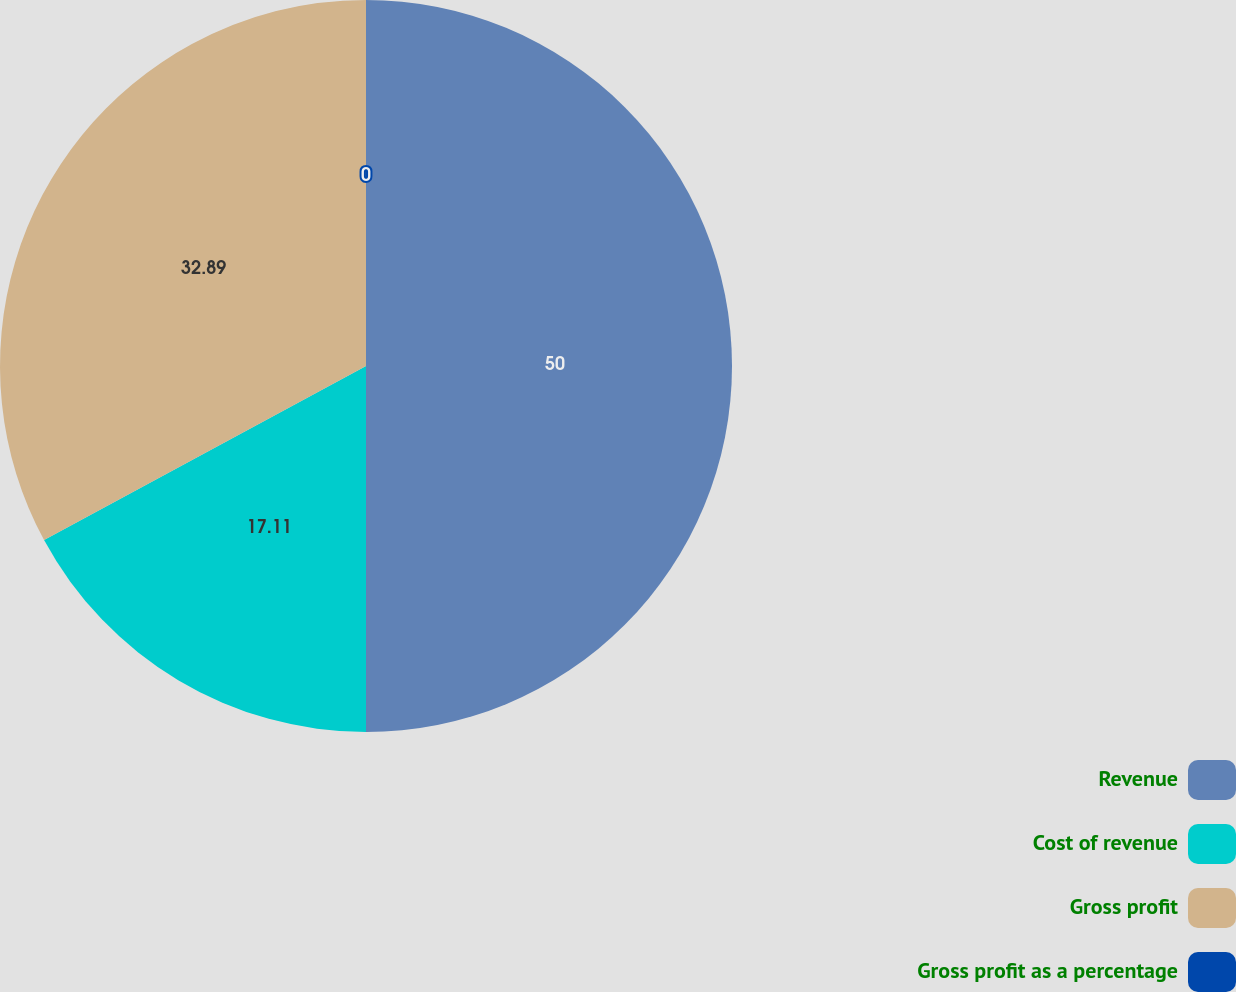Convert chart. <chart><loc_0><loc_0><loc_500><loc_500><pie_chart><fcel>Revenue<fcel>Cost of revenue<fcel>Gross profit<fcel>Gross profit as a percentage<nl><fcel>50.0%<fcel>17.11%<fcel>32.89%<fcel>0.0%<nl></chart> 